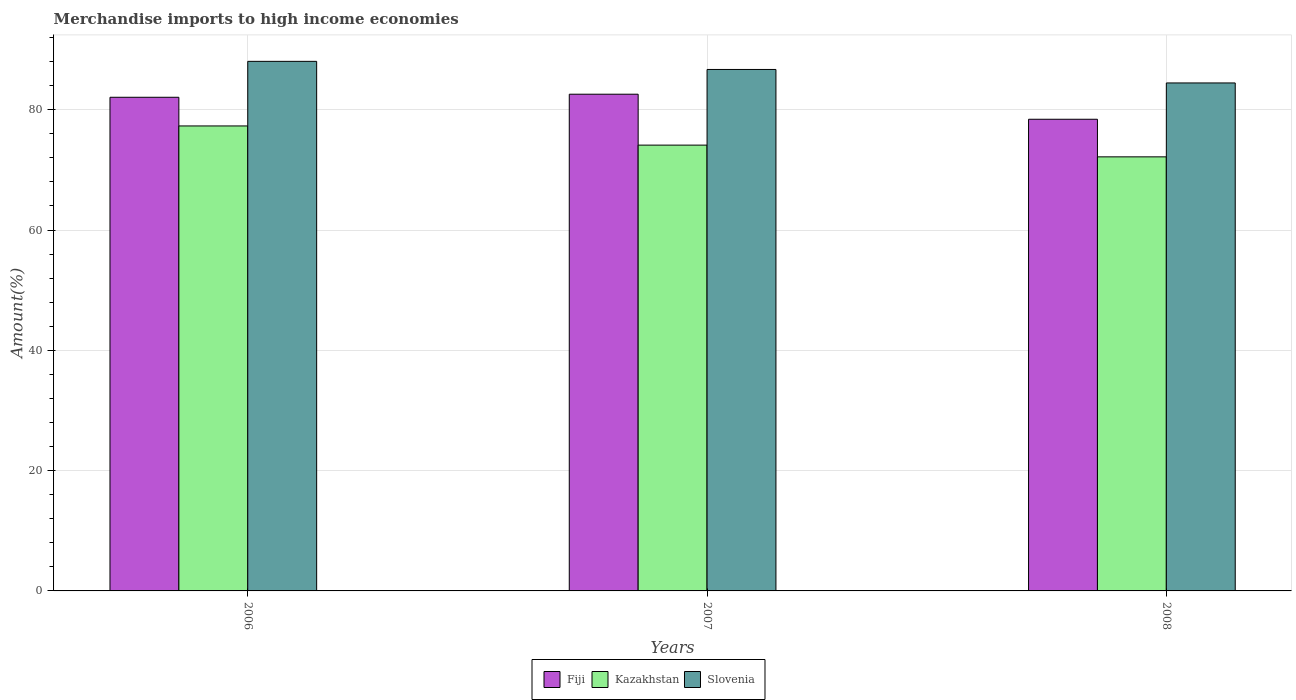Are the number of bars per tick equal to the number of legend labels?
Your answer should be compact. Yes. Are the number of bars on each tick of the X-axis equal?
Ensure brevity in your answer.  Yes. How many bars are there on the 2nd tick from the left?
Your answer should be compact. 3. What is the label of the 1st group of bars from the left?
Offer a terse response. 2006. What is the percentage of amount earned from merchandise imports in Slovenia in 2006?
Offer a very short reply. 88.04. Across all years, what is the maximum percentage of amount earned from merchandise imports in Fiji?
Your answer should be very brief. 82.58. Across all years, what is the minimum percentage of amount earned from merchandise imports in Slovenia?
Offer a very short reply. 84.45. In which year was the percentage of amount earned from merchandise imports in Kazakhstan maximum?
Your answer should be compact. 2006. What is the total percentage of amount earned from merchandise imports in Slovenia in the graph?
Provide a short and direct response. 259.18. What is the difference between the percentage of amount earned from merchandise imports in Fiji in 2006 and that in 2008?
Your answer should be compact. 3.66. What is the difference between the percentage of amount earned from merchandise imports in Kazakhstan in 2008 and the percentage of amount earned from merchandise imports in Fiji in 2006?
Give a very brief answer. -9.91. What is the average percentage of amount earned from merchandise imports in Kazakhstan per year?
Offer a very short reply. 74.53. In the year 2006, what is the difference between the percentage of amount earned from merchandise imports in Fiji and percentage of amount earned from merchandise imports in Kazakhstan?
Give a very brief answer. 4.77. In how many years, is the percentage of amount earned from merchandise imports in Fiji greater than 32 %?
Offer a very short reply. 3. What is the ratio of the percentage of amount earned from merchandise imports in Fiji in 2007 to that in 2008?
Your answer should be very brief. 1.05. What is the difference between the highest and the second highest percentage of amount earned from merchandise imports in Slovenia?
Keep it short and to the point. 1.35. What is the difference between the highest and the lowest percentage of amount earned from merchandise imports in Slovenia?
Provide a succinct answer. 3.59. In how many years, is the percentage of amount earned from merchandise imports in Slovenia greater than the average percentage of amount earned from merchandise imports in Slovenia taken over all years?
Your response must be concise. 2. What does the 1st bar from the left in 2007 represents?
Your response must be concise. Fiji. What does the 2nd bar from the right in 2007 represents?
Give a very brief answer. Kazakhstan. Is it the case that in every year, the sum of the percentage of amount earned from merchandise imports in Slovenia and percentage of amount earned from merchandise imports in Fiji is greater than the percentage of amount earned from merchandise imports in Kazakhstan?
Ensure brevity in your answer.  Yes. How many bars are there?
Offer a terse response. 9. Are all the bars in the graph horizontal?
Offer a very short reply. No. How many years are there in the graph?
Keep it short and to the point. 3. Does the graph contain any zero values?
Offer a very short reply. No. Does the graph contain grids?
Your answer should be compact. Yes. Where does the legend appear in the graph?
Your answer should be very brief. Bottom center. How many legend labels are there?
Your answer should be compact. 3. How are the legend labels stacked?
Offer a very short reply. Horizontal. What is the title of the graph?
Your response must be concise. Merchandise imports to high income economies. Does "Guam" appear as one of the legend labels in the graph?
Keep it short and to the point. No. What is the label or title of the X-axis?
Give a very brief answer. Years. What is the label or title of the Y-axis?
Ensure brevity in your answer.  Amount(%). What is the Amount(%) in Fiji in 2006?
Ensure brevity in your answer.  82.07. What is the Amount(%) in Kazakhstan in 2006?
Give a very brief answer. 77.3. What is the Amount(%) of Slovenia in 2006?
Offer a terse response. 88.04. What is the Amount(%) of Fiji in 2007?
Make the answer very short. 82.58. What is the Amount(%) of Kazakhstan in 2007?
Provide a short and direct response. 74.11. What is the Amount(%) of Slovenia in 2007?
Your answer should be very brief. 86.69. What is the Amount(%) of Fiji in 2008?
Offer a very short reply. 78.41. What is the Amount(%) in Kazakhstan in 2008?
Ensure brevity in your answer.  72.16. What is the Amount(%) of Slovenia in 2008?
Make the answer very short. 84.45. Across all years, what is the maximum Amount(%) in Fiji?
Offer a terse response. 82.58. Across all years, what is the maximum Amount(%) in Kazakhstan?
Your response must be concise. 77.3. Across all years, what is the maximum Amount(%) in Slovenia?
Give a very brief answer. 88.04. Across all years, what is the minimum Amount(%) of Fiji?
Provide a short and direct response. 78.41. Across all years, what is the minimum Amount(%) of Kazakhstan?
Your answer should be compact. 72.16. Across all years, what is the minimum Amount(%) in Slovenia?
Offer a very short reply. 84.45. What is the total Amount(%) of Fiji in the graph?
Your response must be concise. 243.06. What is the total Amount(%) in Kazakhstan in the graph?
Ensure brevity in your answer.  223.58. What is the total Amount(%) in Slovenia in the graph?
Your answer should be compact. 259.18. What is the difference between the Amount(%) of Fiji in 2006 and that in 2007?
Make the answer very short. -0.51. What is the difference between the Amount(%) in Kazakhstan in 2006 and that in 2007?
Give a very brief answer. 3.19. What is the difference between the Amount(%) of Slovenia in 2006 and that in 2007?
Give a very brief answer. 1.35. What is the difference between the Amount(%) in Fiji in 2006 and that in 2008?
Provide a succinct answer. 3.65. What is the difference between the Amount(%) in Kazakhstan in 2006 and that in 2008?
Offer a terse response. 5.14. What is the difference between the Amount(%) in Slovenia in 2006 and that in 2008?
Offer a very short reply. 3.59. What is the difference between the Amount(%) in Fiji in 2007 and that in 2008?
Ensure brevity in your answer.  4.16. What is the difference between the Amount(%) in Kazakhstan in 2007 and that in 2008?
Provide a short and direct response. 1.95. What is the difference between the Amount(%) of Slovenia in 2007 and that in 2008?
Offer a terse response. 2.24. What is the difference between the Amount(%) in Fiji in 2006 and the Amount(%) in Kazakhstan in 2007?
Offer a very short reply. 7.95. What is the difference between the Amount(%) of Fiji in 2006 and the Amount(%) of Slovenia in 2007?
Your answer should be compact. -4.62. What is the difference between the Amount(%) of Kazakhstan in 2006 and the Amount(%) of Slovenia in 2007?
Make the answer very short. -9.39. What is the difference between the Amount(%) of Fiji in 2006 and the Amount(%) of Kazakhstan in 2008?
Provide a succinct answer. 9.91. What is the difference between the Amount(%) in Fiji in 2006 and the Amount(%) in Slovenia in 2008?
Offer a terse response. -2.38. What is the difference between the Amount(%) in Kazakhstan in 2006 and the Amount(%) in Slovenia in 2008?
Give a very brief answer. -7.15. What is the difference between the Amount(%) in Fiji in 2007 and the Amount(%) in Kazakhstan in 2008?
Give a very brief answer. 10.41. What is the difference between the Amount(%) of Fiji in 2007 and the Amount(%) of Slovenia in 2008?
Your answer should be compact. -1.87. What is the difference between the Amount(%) of Kazakhstan in 2007 and the Amount(%) of Slovenia in 2008?
Provide a short and direct response. -10.34. What is the average Amount(%) of Fiji per year?
Give a very brief answer. 81.02. What is the average Amount(%) of Kazakhstan per year?
Provide a short and direct response. 74.53. What is the average Amount(%) in Slovenia per year?
Give a very brief answer. 86.39. In the year 2006, what is the difference between the Amount(%) in Fiji and Amount(%) in Kazakhstan?
Provide a short and direct response. 4.77. In the year 2006, what is the difference between the Amount(%) in Fiji and Amount(%) in Slovenia?
Keep it short and to the point. -5.97. In the year 2006, what is the difference between the Amount(%) of Kazakhstan and Amount(%) of Slovenia?
Give a very brief answer. -10.74. In the year 2007, what is the difference between the Amount(%) in Fiji and Amount(%) in Kazakhstan?
Give a very brief answer. 8.46. In the year 2007, what is the difference between the Amount(%) in Fiji and Amount(%) in Slovenia?
Offer a terse response. -4.12. In the year 2007, what is the difference between the Amount(%) of Kazakhstan and Amount(%) of Slovenia?
Keep it short and to the point. -12.58. In the year 2008, what is the difference between the Amount(%) in Fiji and Amount(%) in Kazakhstan?
Keep it short and to the point. 6.25. In the year 2008, what is the difference between the Amount(%) in Fiji and Amount(%) in Slovenia?
Provide a short and direct response. -6.04. In the year 2008, what is the difference between the Amount(%) in Kazakhstan and Amount(%) in Slovenia?
Keep it short and to the point. -12.29. What is the ratio of the Amount(%) in Fiji in 2006 to that in 2007?
Your response must be concise. 0.99. What is the ratio of the Amount(%) of Kazakhstan in 2006 to that in 2007?
Provide a short and direct response. 1.04. What is the ratio of the Amount(%) of Slovenia in 2006 to that in 2007?
Keep it short and to the point. 1.02. What is the ratio of the Amount(%) of Fiji in 2006 to that in 2008?
Offer a very short reply. 1.05. What is the ratio of the Amount(%) in Kazakhstan in 2006 to that in 2008?
Your answer should be very brief. 1.07. What is the ratio of the Amount(%) of Slovenia in 2006 to that in 2008?
Provide a short and direct response. 1.04. What is the ratio of the Amount(%) of Fiji in 2007 to that in 2008?
Make the answer very short. 1.05. What is the ratio of the Amount(%) in Slovenia in 2007 to that in 2008?
Offer a terse response. 1.03. What is the difference between the highest and the second highest Amount(%) in Fiji?
Provide a short and direct response. 0.51. What is the difference between the highest and the second highest Amount(%) of Kazakhstan?
Offer a very short reply. 3.19. What is the difference between the highest and the second highest Amount(%) in Slovenia?
Ensure brevity in your answer.  1.35. What is the difference between the highest and the lowest Amount(%) in Fiji?
Give a very brief answer. 4.16. What is the difference between the highest and the lowest Amount(%) in Kazakhstan?
Your answer should be compact. 5.14. What is the difference between the highest and the lowest Amount(%) in Slovenia?
Offer a very short reply. 3.59. 